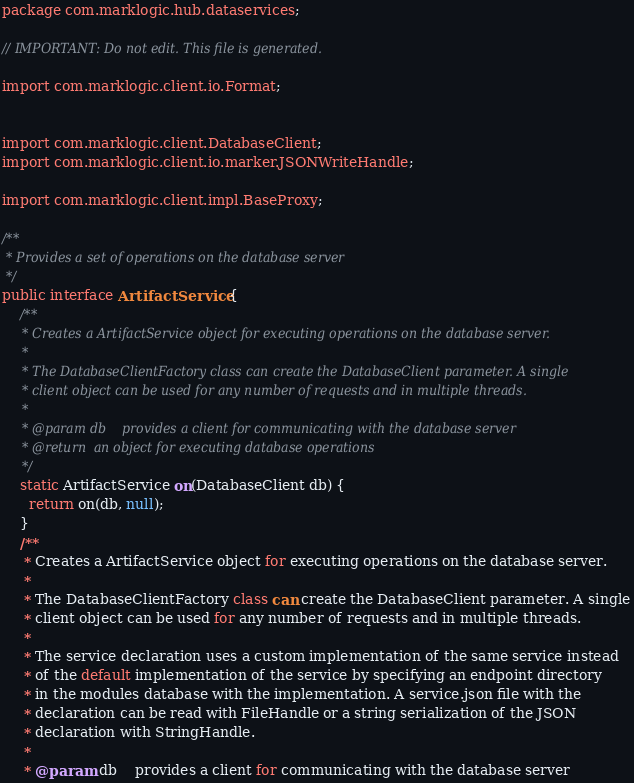Convert code to text. <code><loc_0><loc_0><loc_500><loc_500><_Java_>package com.marklogic.hub.dataservices;

// IMPORTANT: Do not edit. This file is generated.

import com.marklogic.client.io.Format;


import com.marklogic.client.DatabaseClient;
import com.marklogic.client.io.marker.JSONWriteHandle;

import com.marklogic.client.impl.BaseProxy;

/**
 * Provides a set of operations on the database server
 */
public interface ArtifactService {
    /**
     * Creates a ArtifactService object for executing operations on the database server.
     *
     * The DatabaseClientFactory class can create the DatabaseClient parameter. A single
     * client object can be used for any number of requests and in multiple threads.
     *
     * @param db	provides a client for communicating with the database server
     * @return	an object for executing database operations
     */
    static ArtifactService on(DatabaseClient db) {
      return on(db, null);
    }
    /**
     * Creates a ArtifactService object for executing operations on the database server.
     *
     * The DatabaseClientFactory class can create the DatabaseClient parameter. A single
     * client object can be used for any number of requests and in multiple threads.
     *
     * The service declaration uses a custom implementation of the same service instead
     * of the default implementation of the service by specifying an endpoint directory
     * in the modules database with the implementation. A service.json file with the
     * declaration can be read with FileHandle or a string serialization of the JSON
     * declaration with StringHandle.
     *
     * @param db	provides a client for communicating with the database server</code> 